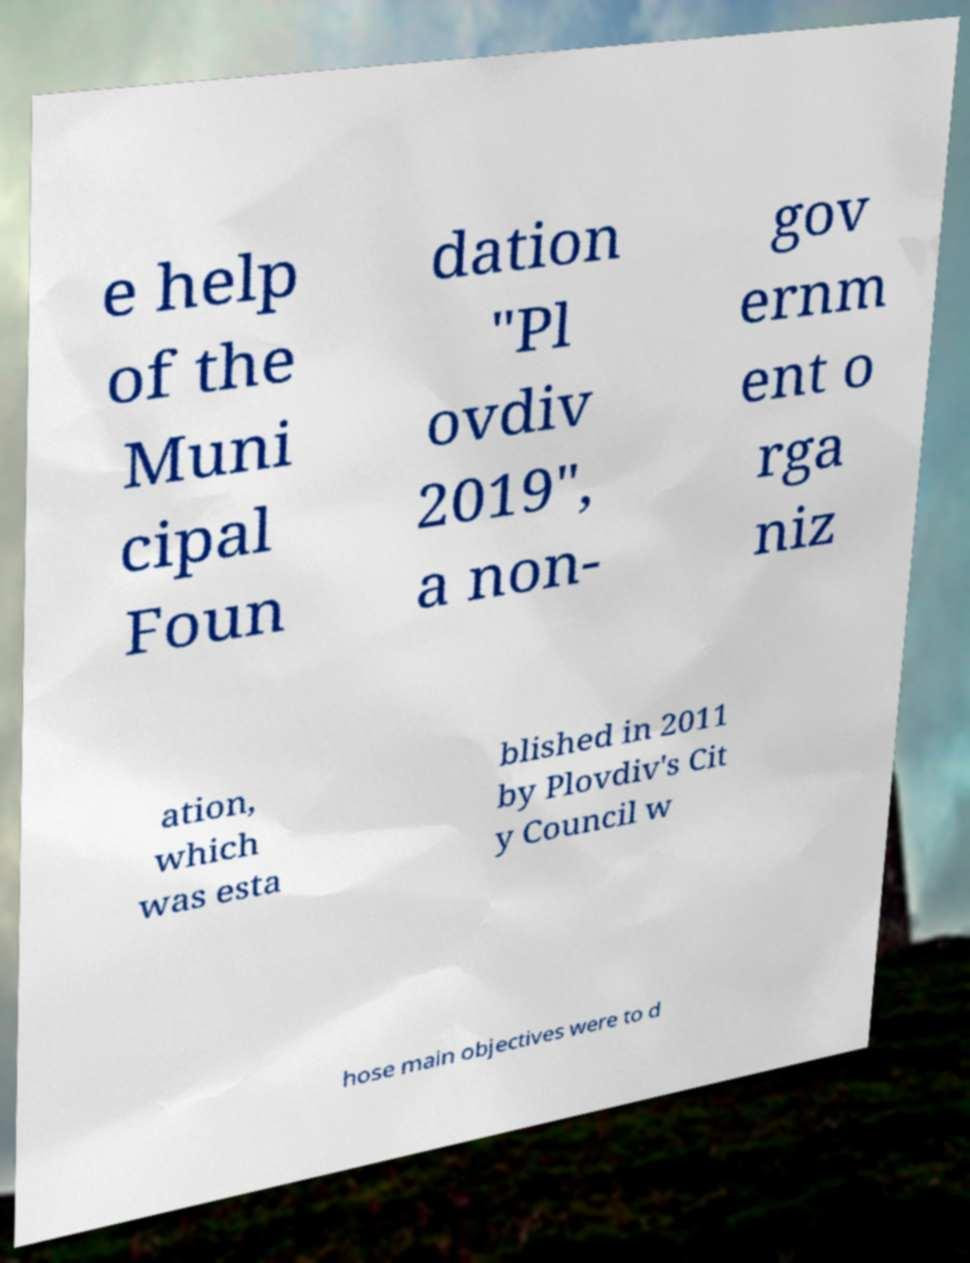I need the written content from this picture converted into text. Can you do that? e help of the Muni cipal Foun dation "Pl ovdiv 2019″, a non- gov ernm ent o rga niz ation, which was esta blished in 2011 by Plovdiv's Cit y Council w hose main objectives were to d 